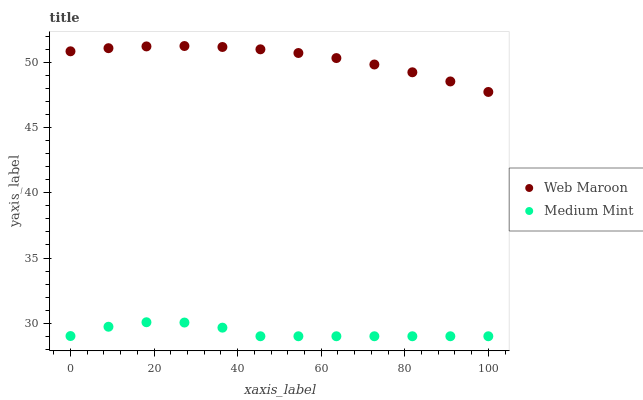Does Medium Mint have the minimum area under the curve?
Answer yes or no. Yes. Does Web Maroon have the maximum area under the curve?
Answer yes or no. Yes. Does Web Maroon have the minimum area under the curve?
Answer yes or no. No. Is Web Maroon the smoothest?
Answer yes or no. Yes. Is Medium Mint the roughest?
Answer yes or no. Yes. Is Web Maroon the roughest?
Answer yes or no. No. Does Medium Mint have the lowest value?
Answer yes or no. Yes. Does Web Maroon have the lowest value?
Answer yes or no. No. Does Web Maroon have the highest value?
Answer yes or no. Yes. Is Medium Mint less than Web Maroon?
Answer yes or no. Yes. Is Web Maroon greater than Medium Mint?
Answer yes or no. Yes. Does Medium Mint intersect Web Maroon?
Answer yes or no. No. 